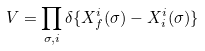<formula> <loc_0><loc_0><loc_500><loc_500>V = \prod _ { \sigma , i } \delta \{ X _ { f } ^ { i } ( \sigma ) - X _ { i } ^ { i } ( \sigma ) \}</formula> 